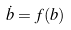Convert formula to latex. <formula><loc_0><loc_0><loc_500><loc_500>\dot { b } = f ( b )</formula> 